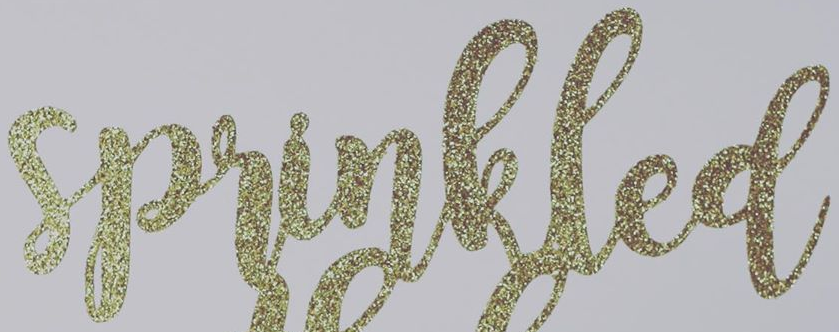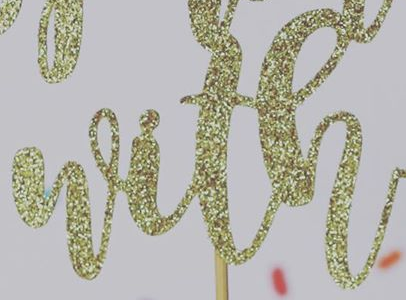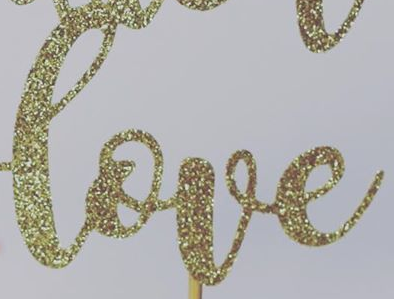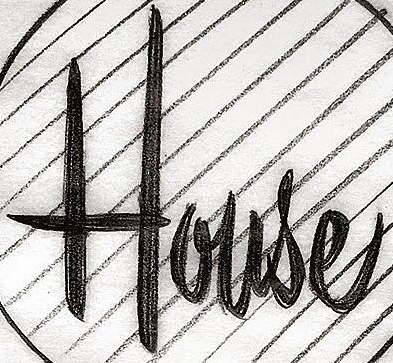Read the text content from these images in order, separated by a semicolon. sprinkled; with; love; House 